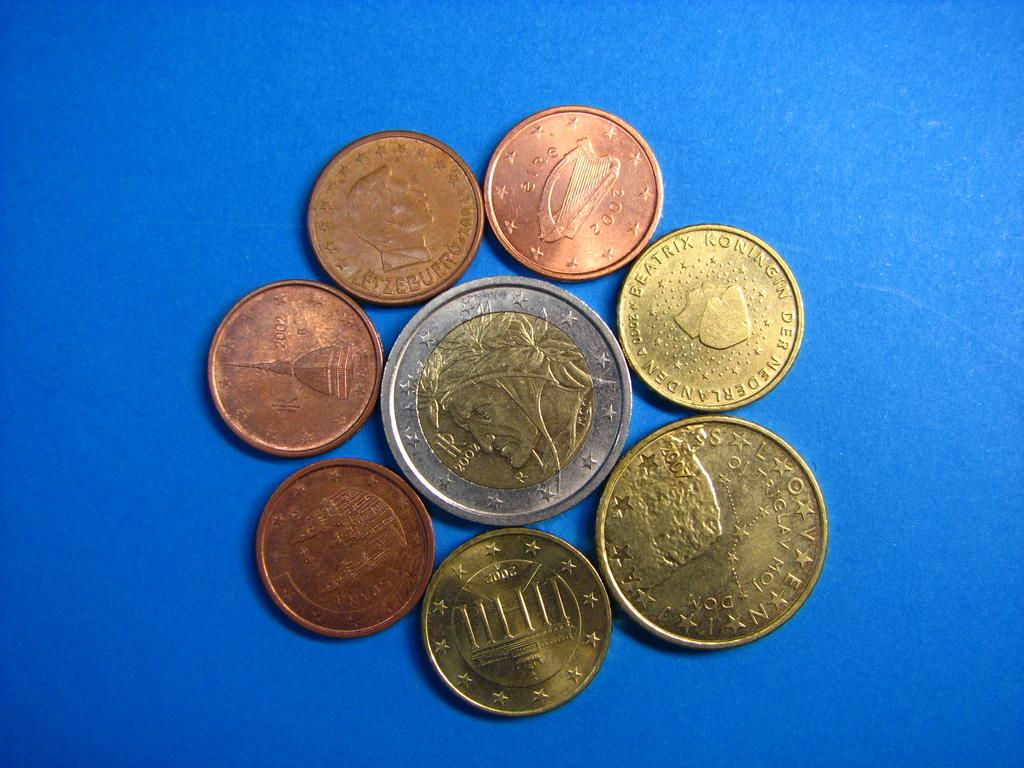Provide a one-sentence caption for the provided image. coins that appear to be from the netherlands. 